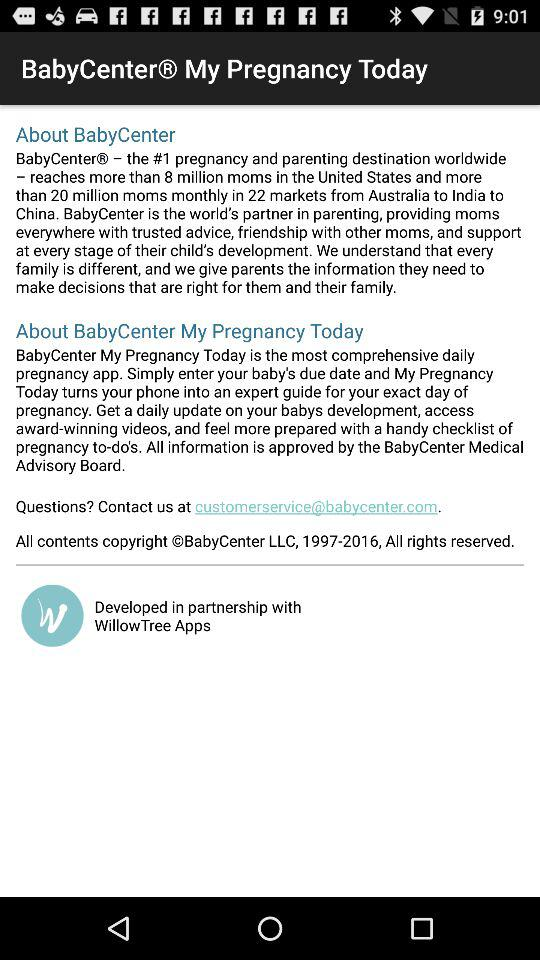What is the name of the application? The name of the application is "BabyCenter My Pregnancy Today". 